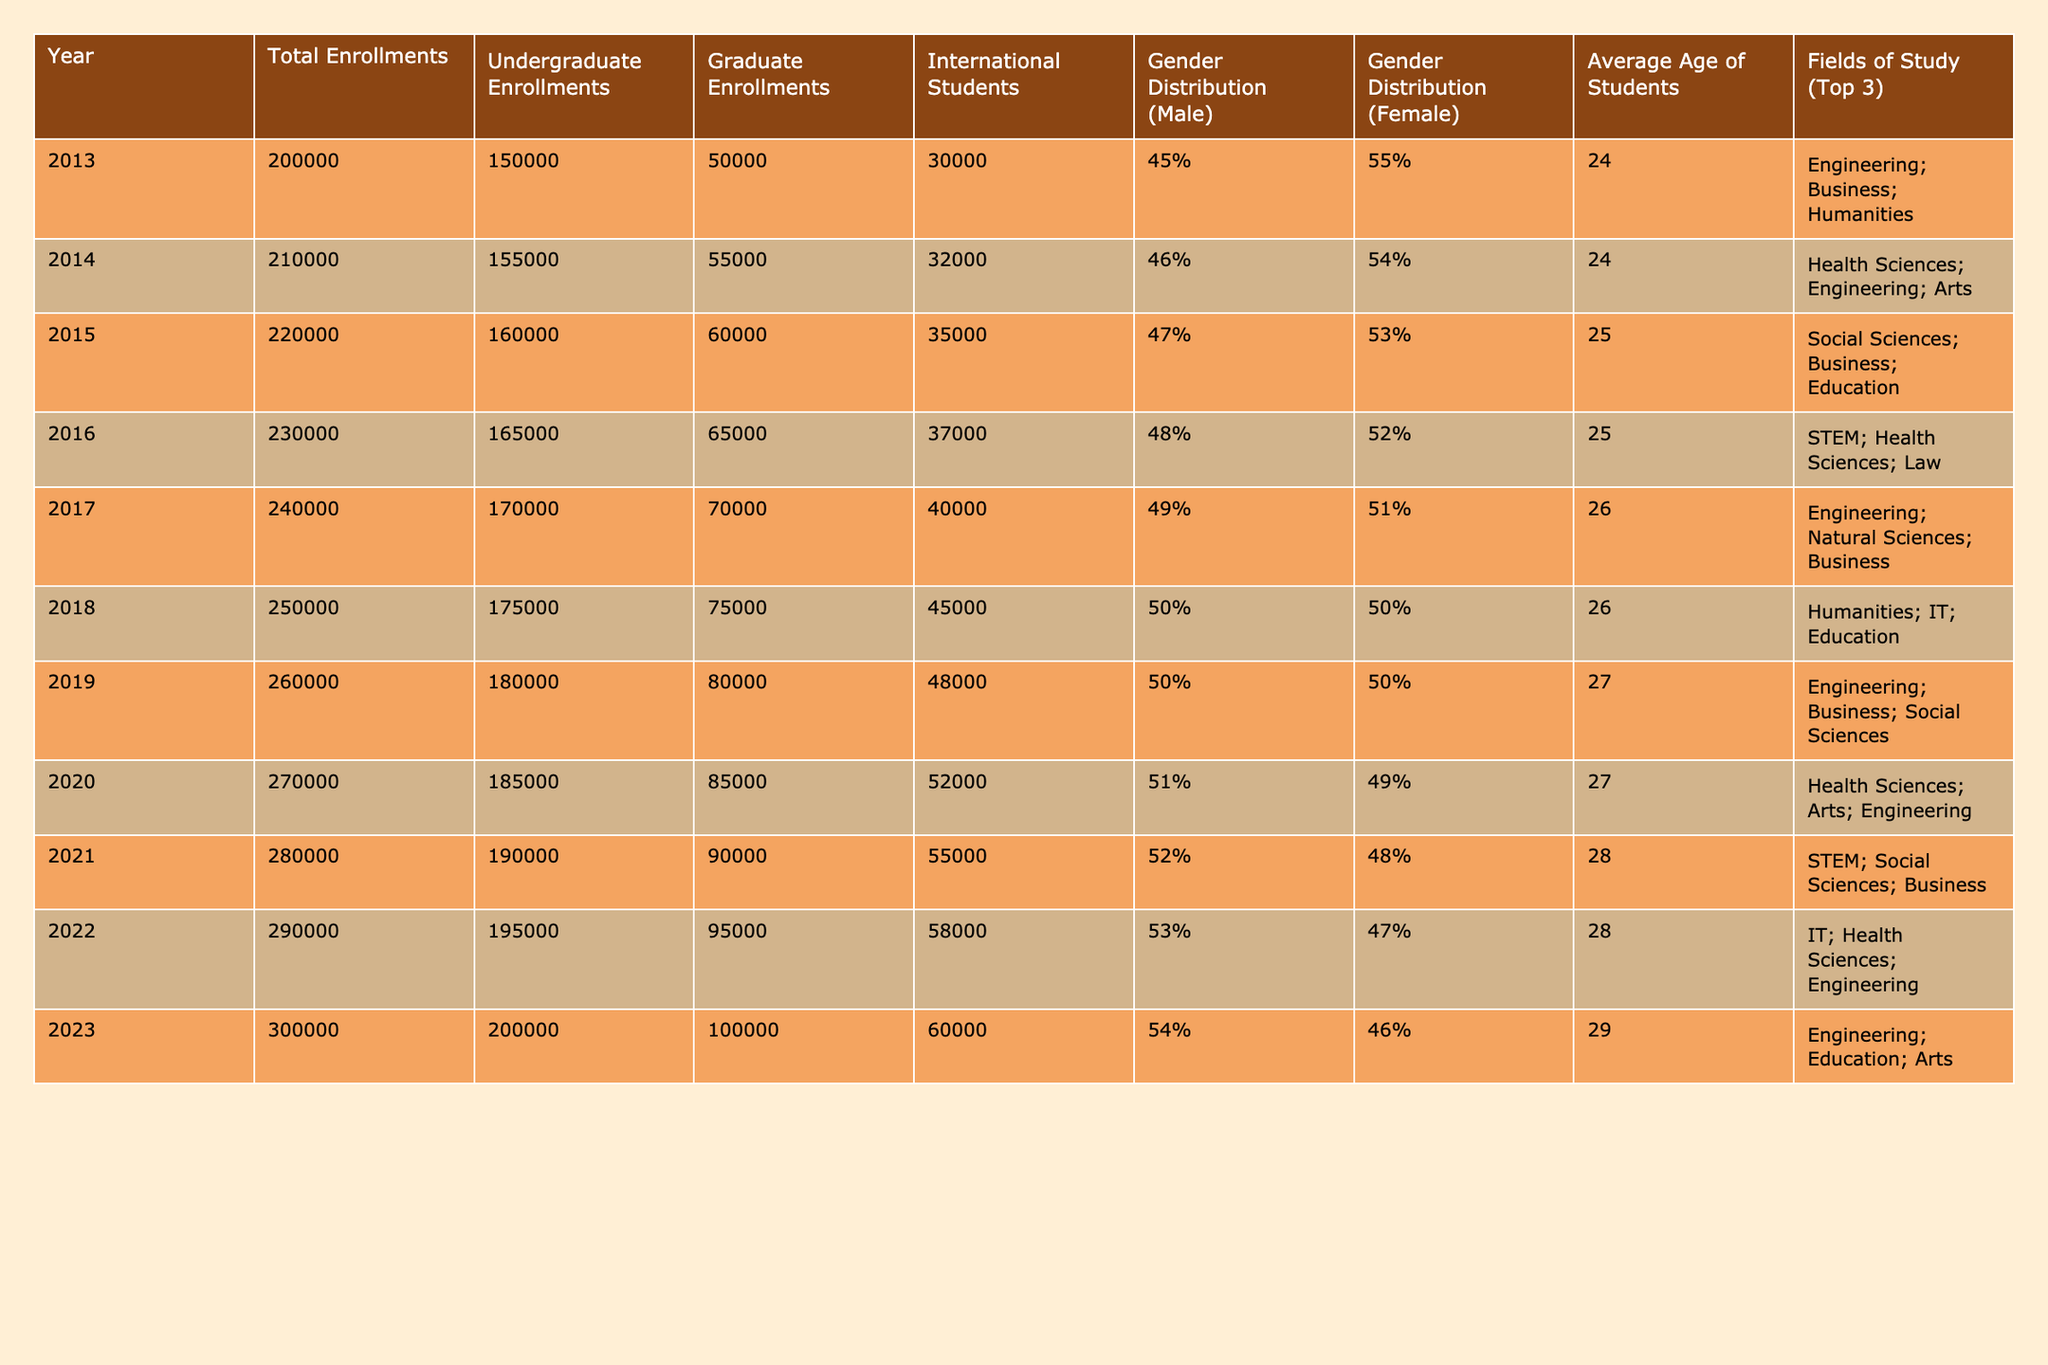What was the total enrollment in 2020? The table shows the total enrollments for the year 2020, which is listed specifically in that row. According to the data, the total enrollments in 2020 were 270,000.
Answer: 270,000 Which year had the highest number of international students? To find the year with the highest number of international students, I need to compare the International Students column across all years. Scanning the data, the year 2023 has the highest value of 60,000.
Answer: 2023 What was the gender distribution percentage of female students in 2015? I can retrieve the gender distribution percentage of female students in 2015 by looking directly at the Gender Distribution (Female) column for that specific year, which shows 53%.
Answer: 53% What was the average age of students in the year with the highest undergraduate enrollments? First, I identify which year had the highest undergraduate enrollments by checking the Undergraduate Enrollments column. The highest value is in 2023 with 200,000. Next, I look in that row to find the Average Age of Students, which is 29.
Answer: 29 Did the total enrollment increase every year from 2013 to 2023? To determine if the total enrollment increased every year, I need to examine the Total Enrollments column year by year from 2013 to 2023 and check for any decreases. The data shows a consistent increase without any years where total enrollments declined.
Answer: Yes By what percentage did graduate enrollments increase from 2013 to 2023? First, I find the graduate enrollments for both years: in 2013, it was 50,000 and in 2023, it was 100,000. The increase is calculated as (100,000 - 50,000) = 50,000. Then, I calculate the percentage increase using the formula: (increase/original number) * 100 = (50,000/50,000) * 100 = 100%.
Answer: 100% In which year did the average age of students first reach 27? By examining the Average Age of Students column, I need to identify the first occurrence of an average age of 27 or older. This occurs in 2019, so that is the earliest year when the average age reached 27.
Answer: 2019 What is the difference in the number of international students between the years 2018 and 2020? I look up the number of international students for both years: in 2018, there were 45,000 and in 2020, there were 52,000. The difference is calculated by subtracting: 52,000 - 45,000 = 7,000.
Answer: 7,000 